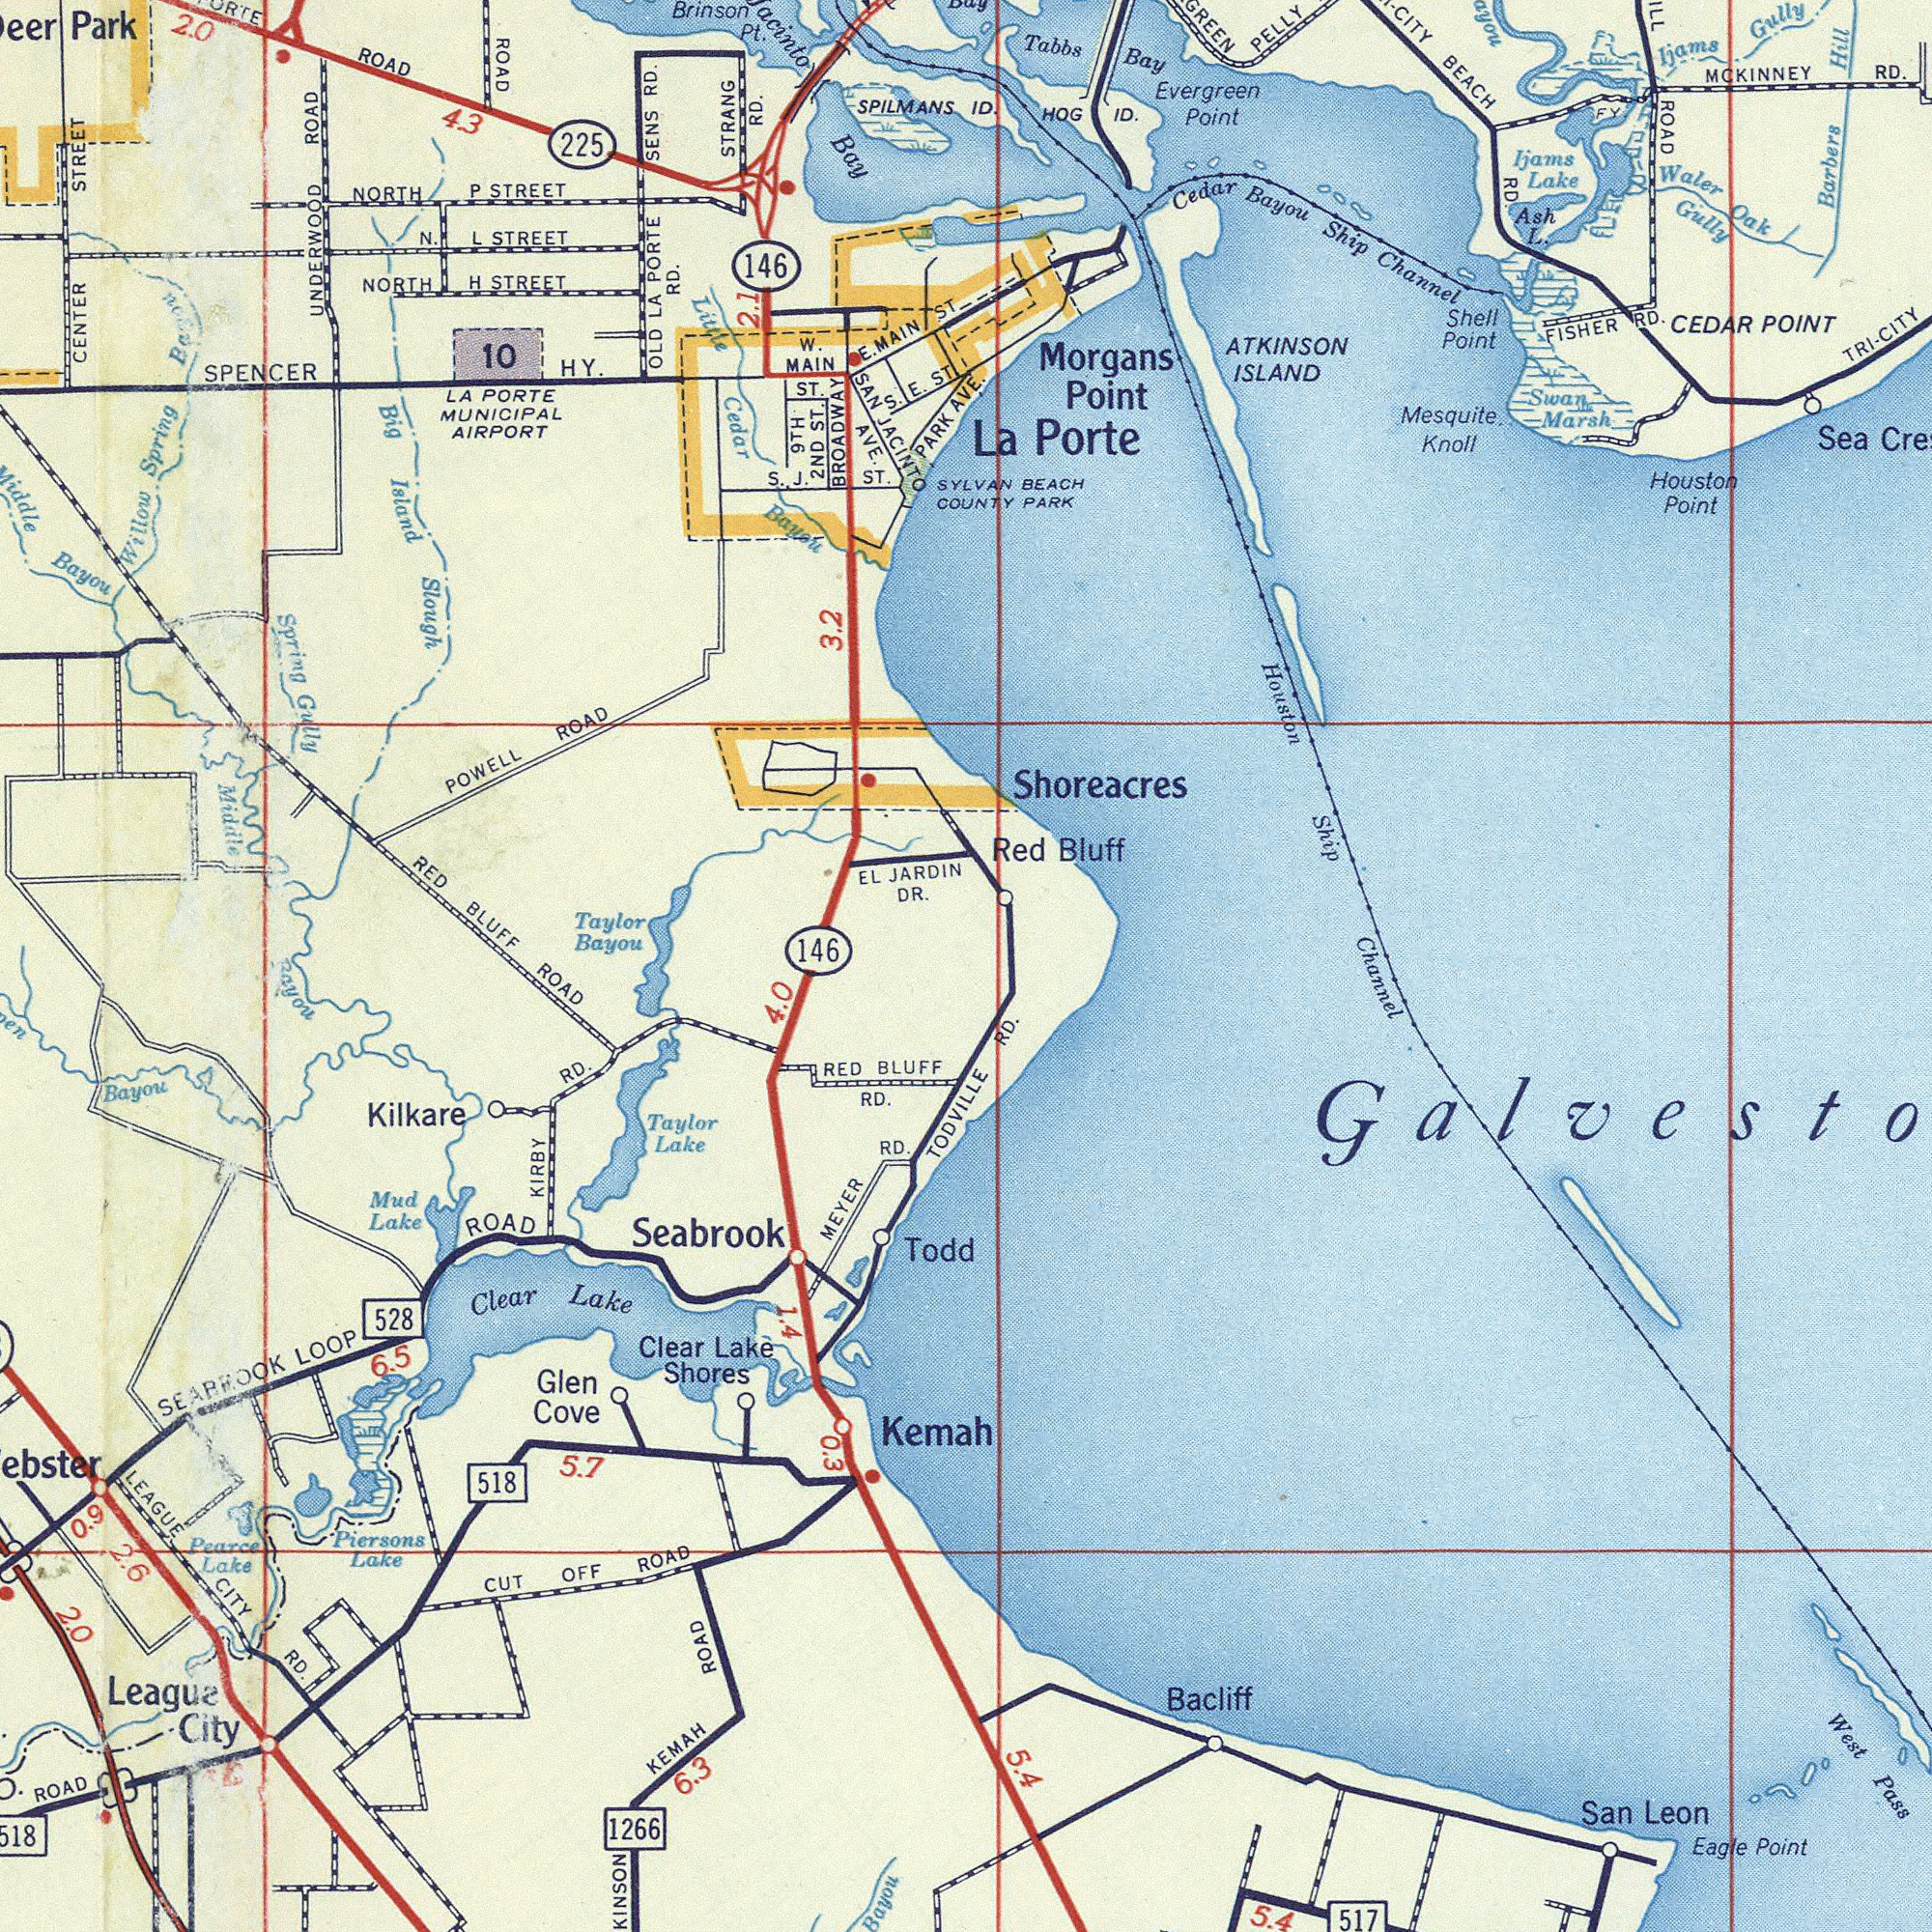What text is visible in the upper-left corner? CENTER STREET SAN JACINTO AVE. Bayou Middle 3.2 146 SENS RD. SPENCER HY. RED BLUFF Park LA PORTE MUNICIPAL AIRPORT 225 STRANG RD. OLD LA PORTE RD. Big Island Slough UNDERWOOD ROAD Taylor Bayou Spring Gully ROAD EL JARDIN DR. POWELL ROAD Little Cedar Bayou ROAD 10 Brinson Pt. N. L STREET 146 Willow Spring Bayou Bay NORTH P STREET W. MAIN ST. SPILMANS S. E. ST NORTH H. STREET PARK AVE. BROADWAY S. J. ST. 2 ND ST. E. MAIN ST. SYIVAN COUNTY 2.0 4.3 9 TH Bay 2.1 What text is visible in the lower-right corner? Channel RD. 5.4 5.4 San Leon West Pass 517 Eagle Point Bacliff What text appears in the bottom-left area of the image? Bayou ROAD 4.0 Seabrook Clear Lake Shores KIRBY RD. 2.0 RED BLUFF RD. Kilkare Leaguz City CUT OFF ROAD MEYER RD. SEARFOOK LOOP ROAD 6.3 KINSON KEMAH ROAD LEAGUE CITY RD. Clear Lake 528 Bayou 5.7 ROAD Piersons Lake 6.5 1266 0.9 518 Pearce Lake Taylor Lake Mud Lake Bayou Kemah TODVILLE Glen Cove Todd 0.3 2.6 1.4 What text is shown in the top-right quadrant? ID. Shoreacres MCKINNEY RD. Houston Ship La Porte ATKINSON ISLAND CEDAR POINT Evergreen Point CITY BEACH RD. Cedar Bayou Ship Channel Barbers Hill Mesquite Knoll Tabbs Bay FISHER RD. ROAD Waler Oak Gully Swan Marsh Shell Point Red Bluff HOG ID. Morgans Point BEACH PARK PELLY Ijams Lake Houston Point Sea Ijams Gully Ash L. TRI-CITY FY 